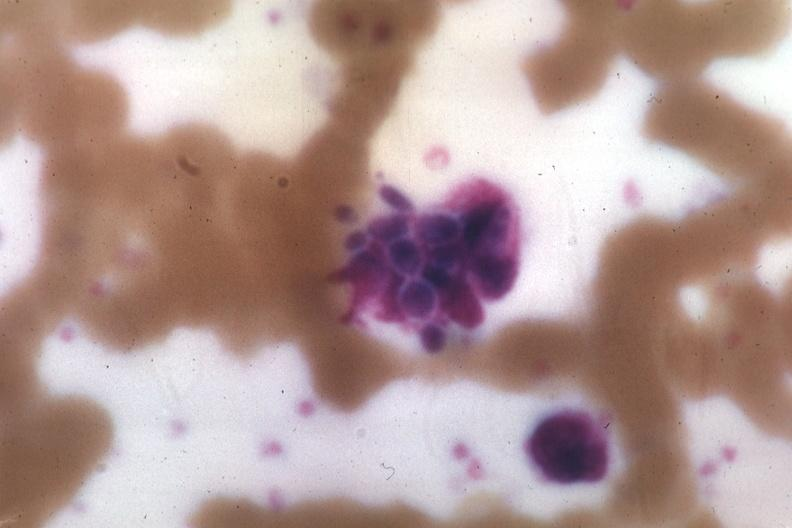s hematologic present?
Answer the question using a single word or phrase. Yes 